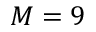Convert formula to latex. <formula><loc_0><loc_0><loc_500><loc_500>M = 9</formula> 